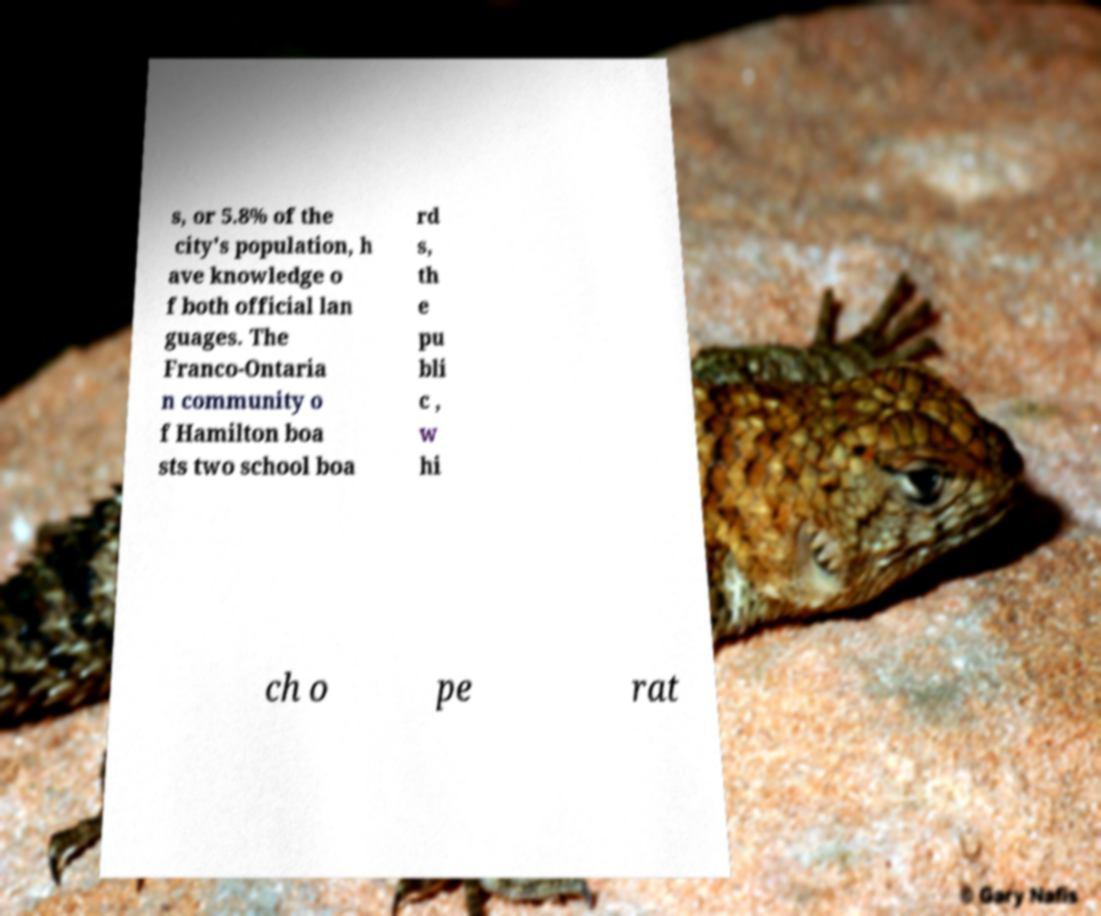Please read and relay the text visible in this image. What does it say? s, or 5.8% of the city's population, h ave knowledge o f both official lan guages. The Franco-Ontaria n community o f Hamilton boa sts two school boa rd s, th e pu bli c , w hi ch o pe rat 